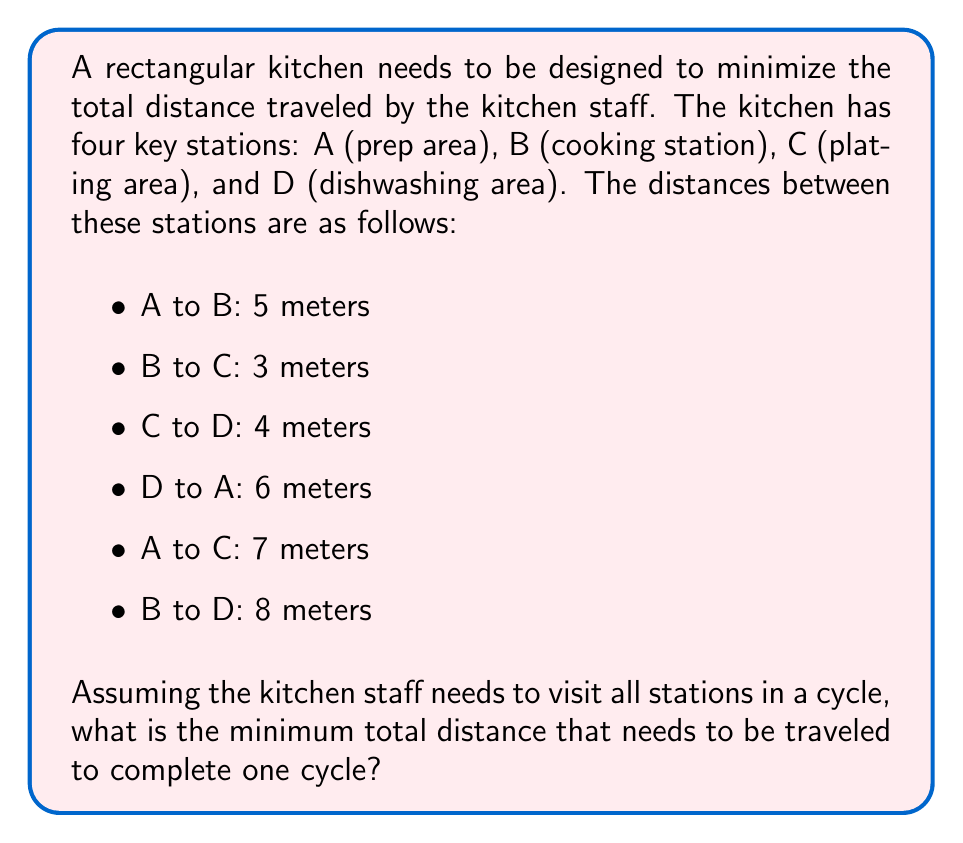Give your solution to this math problem. To solve this problem, we need to find the shortest path that visits all stations exactly once and returns to the starting point. This is known as the Traveling Salesman Problem (TSP).

Given the small number of stations, we can solve this by considering all possible permutations:

1. A → B → C → D → A: $5 + 3 + 4 + 6 = 18$ meters
2. A → B → D → C → A: $5 + 8 + 4 + 7 = 24$ meters
3. A → C → B → D → A: $7 + 3 + 8 + 6 = 24$ meters
4. A → C → D → B → A: $7 + 4 + 8 + 5 = 24$ meters
5. A → D → B → C → A: $6 + 8 + 3 + 7 = 24$ meters
6. A → D → C → B → A: $6 + 4 + 3 + 5 = 18$ meters

We can see that there are two optimal paths:
1. A → B → C → D → A
2. A → D → C → B → A

Both of these paths result in a total distance of 18 meters.

To visualize this, we can represent the kitchen layout as a graph:

[asy]
unitsize(1cm);

pair A = (0,0), B = (5,0), C = (5,3), D = (0,3);

draw(A--B--C--D--cycle, blue);
draw(A--C, red);
draw(B--D, red);

dot("A", A, SW);
dot("B", B, SE);
dot("C", C, NE);
dot("D", D, NW);

label("5", (A+B)/2, S);
label("3", (B+C)/2, E);
label("4", (C+D)/2, N);
label("6", (A+D)/2, W);
label("7", (A+C)/2, NE);
label("8", (B+D)/2, NW);
[/asy]

The blue lines represent the optimal path, while the red lines show the other possible connections.
Answer: The minimum total distance that needs to be traveled to complete one cycle visiting all stations is 18 meters. 